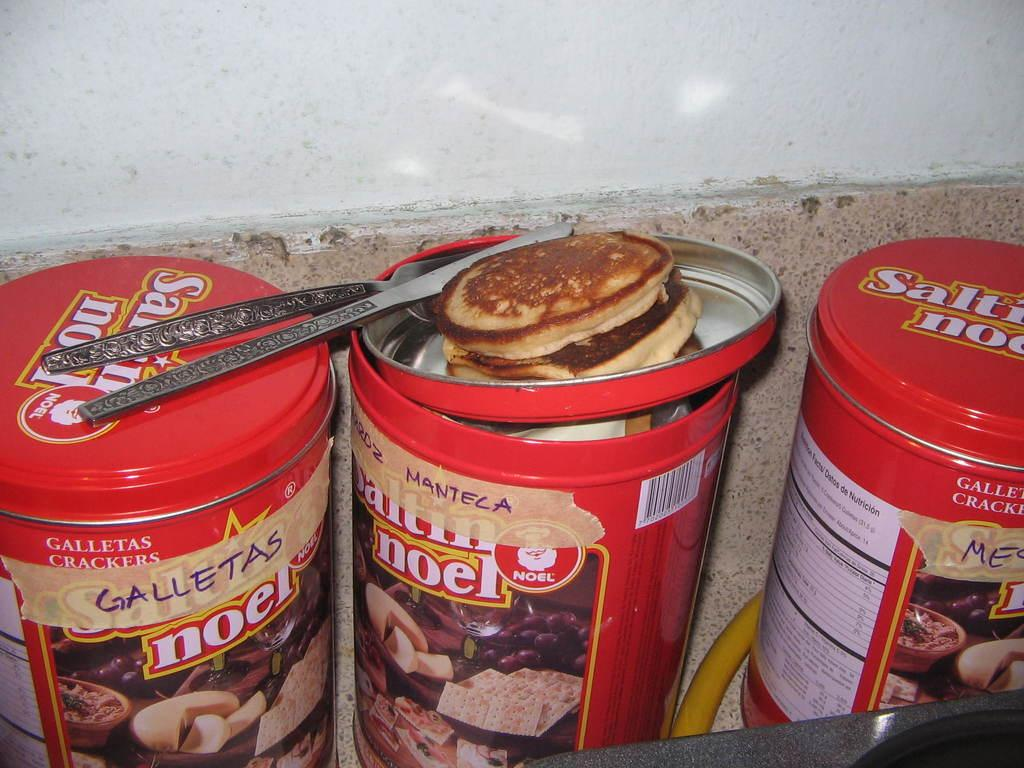What objects are present in the image? There are boxes in the image. What is placed on top of the boxes? There are food items placed on the boxes. What type of badge can be seen on the boxes in the image? There is no badge present on the boxes in the image. What kind of music is being played in the background of the image? There is no music or indication of sound in the image. 